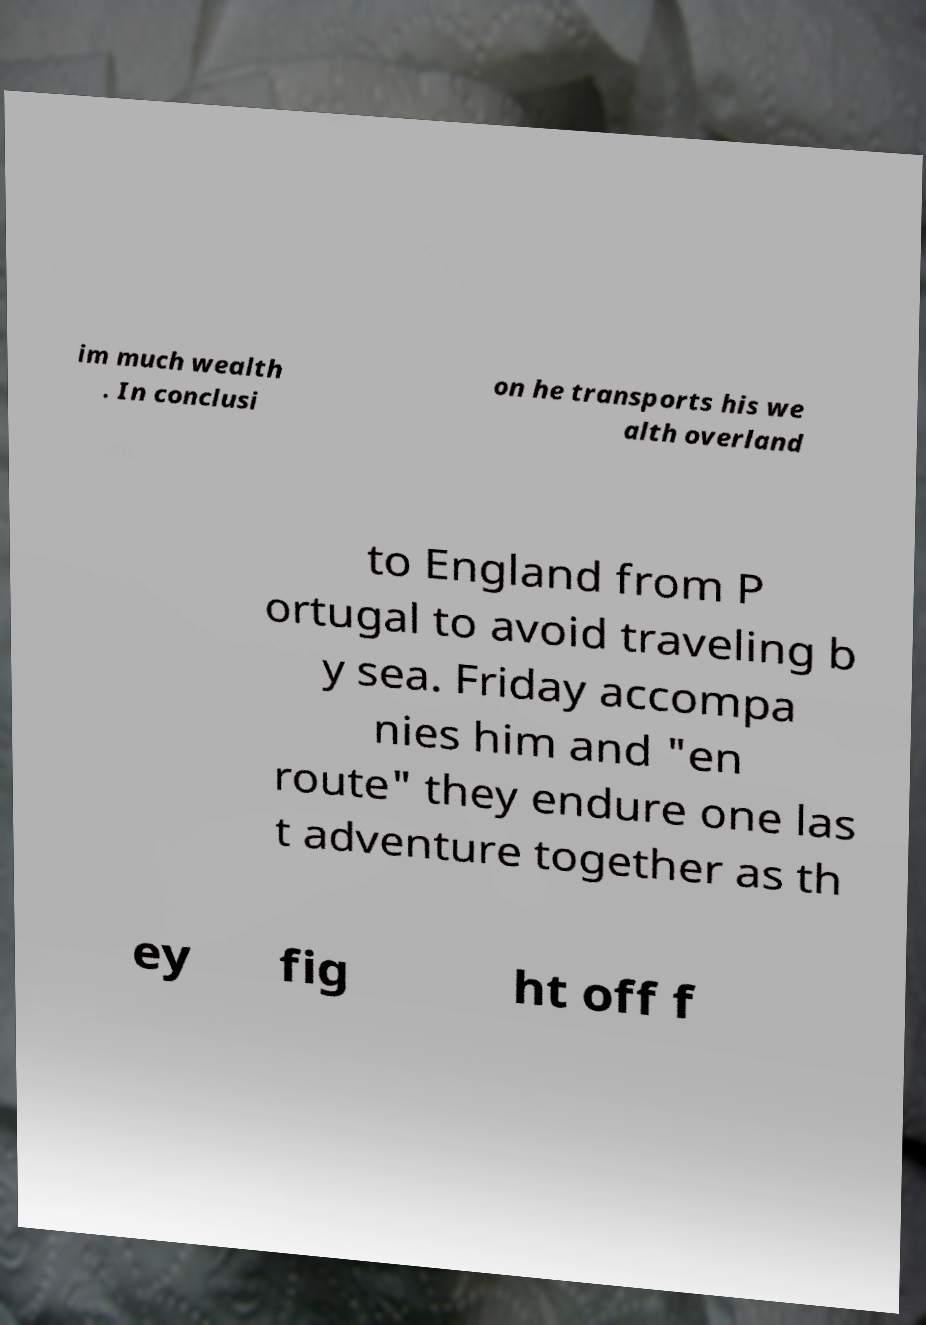Could you assist in decoding the text presented in this image and type it out clearly? im much wealth . In conclusi on he transports his we alth overland to England from P ortugal to avoid traveling b y sea. Friday accompa nies him and "en route" they endure one las t adventure together as th ey fig ht off f 